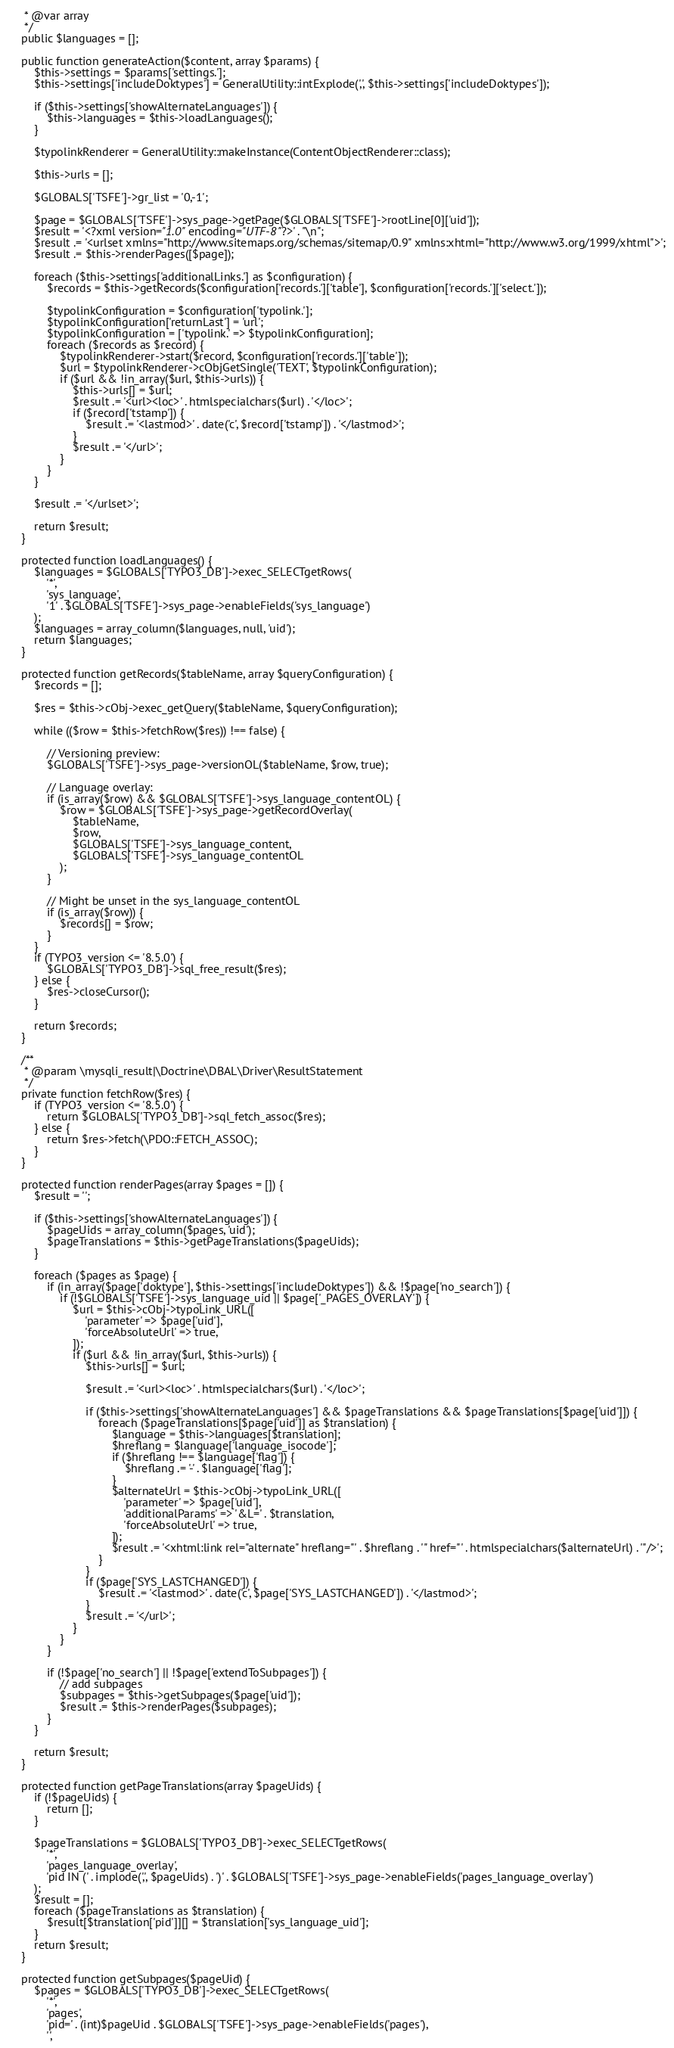<code> <loc_0><loc_0><loc_500><loc_500><_PHP_>	 * @var array
	 */
	public $languages = [];

	public function generateAction($content, array $params) {
		$this->settings = $params['settings.'];
		$this->settings['includeDoktypes'] = GeneralUtility::intExplode(',', $this->settings['includeDoktypes']);

		if ($this->settings['showAlternateLanguages']) {
			$this->languages = $this->loadLanguages();
		}

		$typolinkRenderer = GeneralUtility::makeInstance(ContentObjectRenderer::class);

		$this->urls = [];

		$GLOBALS['TSFE']->gr_list = '0,-1';

		$page = $GLOBALS['TSFE']->sys_page->getPage($GLOBALS['TSFE']->rootLine[0]['uid']);
		$result = '<?xml version="1.0" encoding="UTF-8"?>' . "\n";
		$result .= '<urlset xmlns="http://www.sitemaps.org/schemas/sitemap/0.9" xmlns:xhtml="http://www.w3.org/1999/xhtml">';
		$result .= $this->renderPages([$page]);

		foreach ($this->settings['additionalLinks.'] as $configuration) {
			$records = $this->getRecords($configuration['records.']['table'], $configuration['records.']['select.']);

			$typolinkConfiguration = $configuration['typolink.'];
			$typolinkConfiguration['returnLast'] = 'url';
			$typolinkConfiguration = ['typolink.' => $typolinkConfiguration];
			foreach ($records as $record) {
				$typolinkRenderer->start($record, $configuration['records.']['table']);
				$url = $typolinkRenderer->cObjGetSingle('TEXT', $typolinkConfiguration);
				if ($url && !in_array($url, $this->urls)) {
					$this->urls[] = $url;
					$result .= '<url><loc>' . htmlspecialchars($url) . '</loc>';
					if ($record['tstamp']) {
						$result .= '<lastmod>' . date('c', $record['tstamp']) . '</lastmod>';
					}
					$result .= '</url>';
				}
			}
		}

		$result .= '</urlset>';

		return $result;
	}

	protected function loadLanguages() {
		$languages = $GLOBALS['TYPO3_DB']->exec_SELECTgetRows(
			'*',
			'sys_language',
			'1' . $GLOBALS['TSFE']->sys_page->enableFields('sys_language')
		);
		$languages = array_column($languages, null, 'uid');
		return $languages;
	}

	protected function getRecords($tableName, array $queryConfiguration) {
		$records = [];

		$res = $this->cObj->exec_getQuery($tableName, $queryConfiguration);

		while (($row = $this->fetchRow($res)) !== false) {

			// Versioning preview:
			$GLOBALS['TSFE']->sys_page->versionOL($tableName, $row, true);

			// Language overlay:
			if (is_array($row) && $GLOBALS['TSFE']->sys_language_contentOL) {
				$row = $GLOBALS['TSFE']->sys_page->getRecordOverlay(
					$tableName,
					$row,
					$GLOBALS['TSFE']->sys_language_content,
					$GLOBALS['TSFE']->sys_language_contentOL
				);
			}

			// Might be unset in the sys_language_contentOL
			if (is_array($row)) {
				$records[] = $row;
			}
		}
		if (TYPO3_version <= '8.5.0') {
			$GLOBALS['TYPO3_DB']->sql_free_result($res);
		} else {
			$res->closeCursor();
		}

		return $records;
	}

	/**
	 * @param \mysqli_result|\Doctrine\DBAL\Driver\ResultStatement
	 */
	private function fetchRow($res) {
		if (TYPO3_version <= '8.5.0') {
			return $GLOBALS['TYPO3_DB']->sql_fetch_assoc($res);
		} else {
			return $res->fetch(\PDO::FETCH_ASSOC);
		}
	}

	protected function renderPages(array $pages = []) {
		$result = '';

		if ($this->settings['showAlternateLanguages']) {
			$pageUids = array_column($pages, 'uid');
			$pageTranslations = $this->getPageTranslations($pageUids);
		}

		foreach ($pages as $page) {
			if (in_array($page['doktype'], $this->settings['includeDoktypes']) && !$page['no_search']) {
				if (!$GLOBALS['TSFE']->sys_language_uid || $page['_PAGES_OVERLAY']) {
					$url = $this->cObj->typoLink_URL([
						'parameter' => $page['uid'],
						'forceAbsoluteUrl' => true,
					]);
					if ($url && !in_array($url, $this->urls)) {
						$this->urls[] = $url;

						$result .= '<url><loc>' . htmlspecialchars($url) . '</loc>';

						if ($this->settings['showAlternateLanguages'] && $pageTranslations && $pageTranslations[$page['uid']]) {
							foreach ($pageTranslations[$page['uid']] as $translation) {
								$language = $this->languages[$translation];
								$hreflang = $language['language_isocode'];
								if ($hreflang !== $language['flag']) {
									$hreflang .= '-' . $language['flag'];
								}
								$alternateUrl = $this->cObj->typoLink_URL([
									'parameter' => $page['uid'],
									'additionalParams' => '&L=' . $translation,
									'forceAbsoluteUrl' => true,
								]);
								$result .= '<xhtml:link rel="alternate" hreflang="' . $hreflang . '" href="' . htmlspecialchars($alternateUrl) . '"/>';
							}
						}
						if ($page['SYS_LASTCHANGED']) {
							$result .= '<lastmod>' . date('c', $page['SYS_LASTCHANGED']) . '</lastmod>';
						}
						$result .= '</url>';
					}
				}
			}

			if (!$page['no_search'] || !$page['extendToSubpages']) {
				// add subpages
				$subpages = $this->getSubpages($page['uid']);
				$result .= $this->renderPages($subpages);
			}
		}

		return $result;
	}

	protected function getPageTranslations(array $pageUids) {
		if (!$pageUids) {
			return [];
		}

		$pageTranslations = $GLOBALS['TYPO3_DB']->exec_SELECTgetRows(
			'*',
			'pages_language_overlay',
			'pid IN (' . implode(',', $pageUids) . ')' . $GLOBALS['TSFE']->sys_page->enableFields('pages_language_overlay')
		);
		$result = [];
		foreach ($pageTranslations as $translation) {
			$result[$translation['pid']][] = $translation['sys_language_uid'];
		}
		return $result;
	}

	protected function getSubpages($pageUid) {
		$pages = $GLOBALS['TYPO3_DB']->exec_SELECTgetRows(
			'*',
			'pages',
			'pid=' . (int)$pageUid . $GLOBALS['TSFE']->sys_page->enableFields('pages'),
			'',</code> 